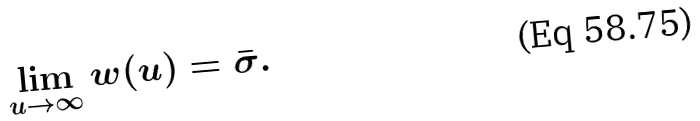Convert formula to latex. <formula><loc_0><loc_0><loc_500><loc_500>\lim _ { u \rightarrow \infty } w ( u ) = \bar { \sigma } .</formula> 